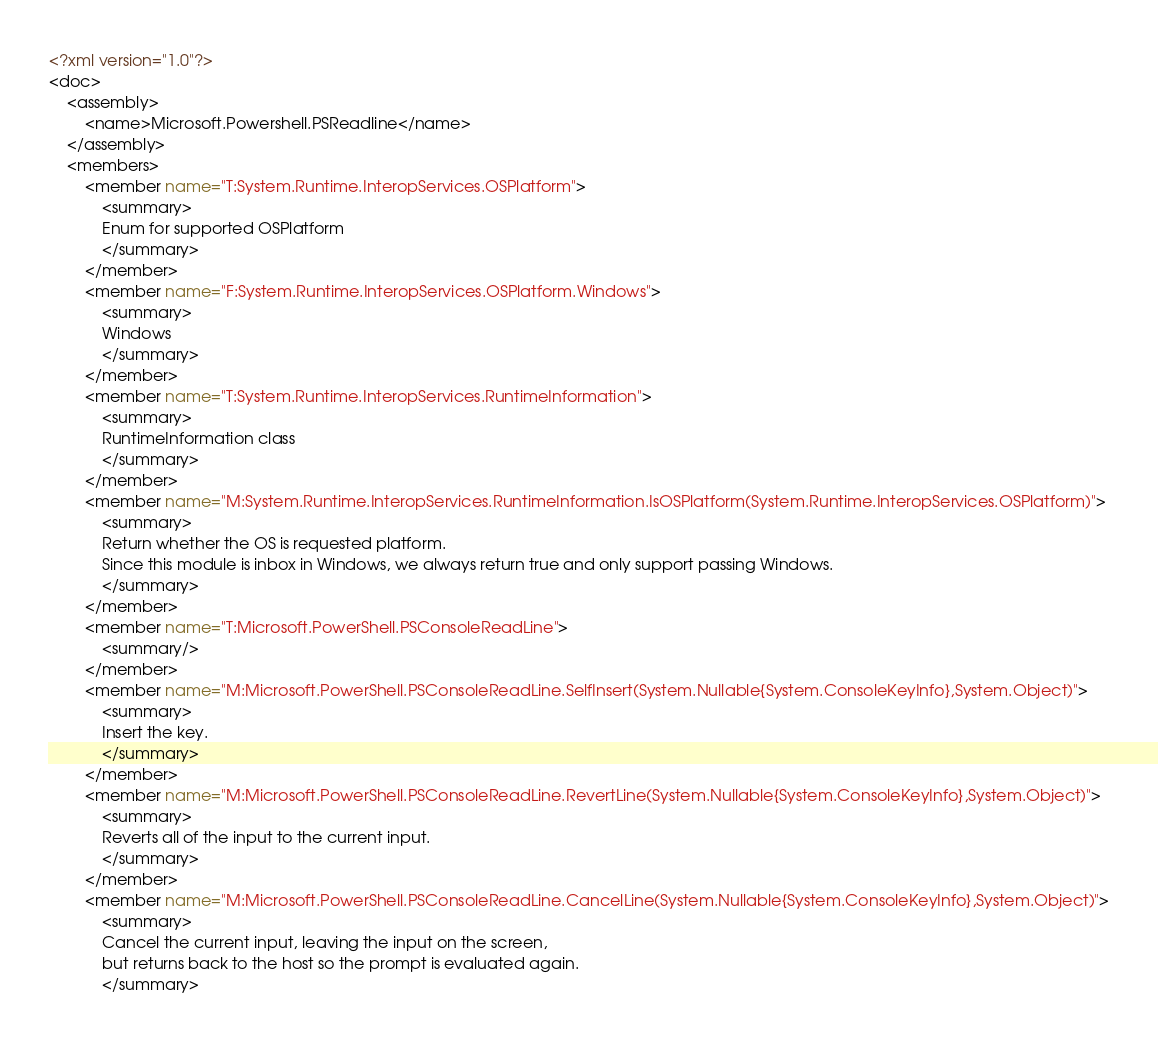<code> <loc_0><loc_0><loc_500><loc_500><_XML_><?xml version="1.0"?>
<doc>
    <assembly>
        <name>Microsoft.Powershell.PSReadline</name>
    </assembly>
    <members>
        <member name="T:System.Runtime.InteropServices.OSPlatform">
            <summary>
            Enum for supported OSPlatform
            </summary>
        </member>
        <member name="F:System.Runtime.InteropServices.OSPlatform.Windows">
            <summary>
            Windows
            </summary>
        </member>
        <member name="T:System.Runtime.InteropServices.RuntimeInformation">
            <summary>
            RuntimeInformation class
            </summary>
        </member>
        <member name="M:System.Runtime.InteropServices.RuntimeInformation.IsOSPlatform(System.Runtime.InteropServices.OSPlatform)">
            <summary>
            Return whether the OS is requested platform.
            Since this module is inbox in Windows, we always return true and only support passing Windows.
            </summary>
        </member>
        <member name="T:Microsoft.PowerShell.PSConsoleReadLine">
            <summary/>
        </member>
        <member name="M:Microsoft.PowerShell.PSConsoleReadLine.SelfInsert(System.Nullable{System.ConsoleKeyInfo},System.Object)">
            <summary>
            Insert the key.
            </summary>
        </member>
        <member name="M:Microsoft.PowerShell.PSConsoleReadLine.RevertLine(System.Nullable{System.ConsoleKeyInfo},System.Object)">
            <summary>
            Reverts all of the input to the current input.
            </summary>
        </member>
        <member name="M:Microsoft.PowerShell.PSConsoleReadLine.CancelLine(System.Nullable{System.ConsoleKeyInfo},System.Object)">
            <summary>
            Cancel the current input, leaving the input on the screen,
            but returns back to the host so the prompt is evaluated again.
            </summary></code> 